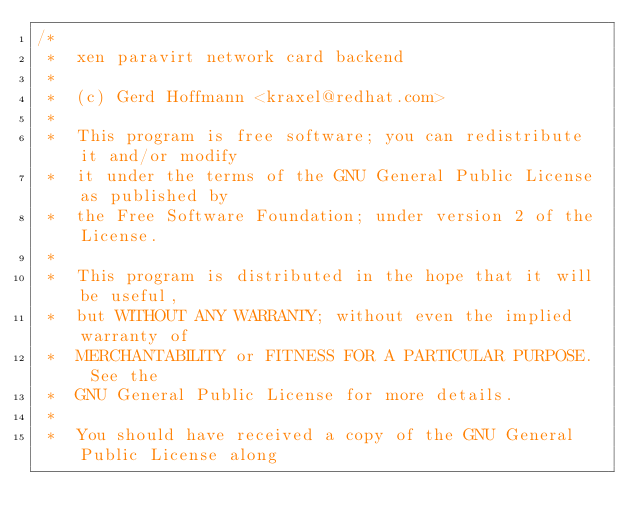Convert code to text. <code><loc_0><loc_0><loc_500><loc_500><_C_>/*
 *  xen paravirt network card backend
 *
 *  (c) Gerd Hoffmann <kraxel@redhat.com>
 *
 *  This program is free software; you can redistribute it and/or modify
 *  it under the terms of the GNU General Public License as published by
 *  the Free Software Foundation; under version 2 of the License.
 *
 *  This program is distributed in the hope that it will be useful,
 *  but WITHOUT ANY WARRANTY; without even the implied warranty of
 *  MERCHANTABILITY or FITNESS FOR A PARTICULAR PURPOSE.  See the
 *  GNU General Public License for more details.
 *
 *  You should have received a copy of the GNU General Public License along</code> 